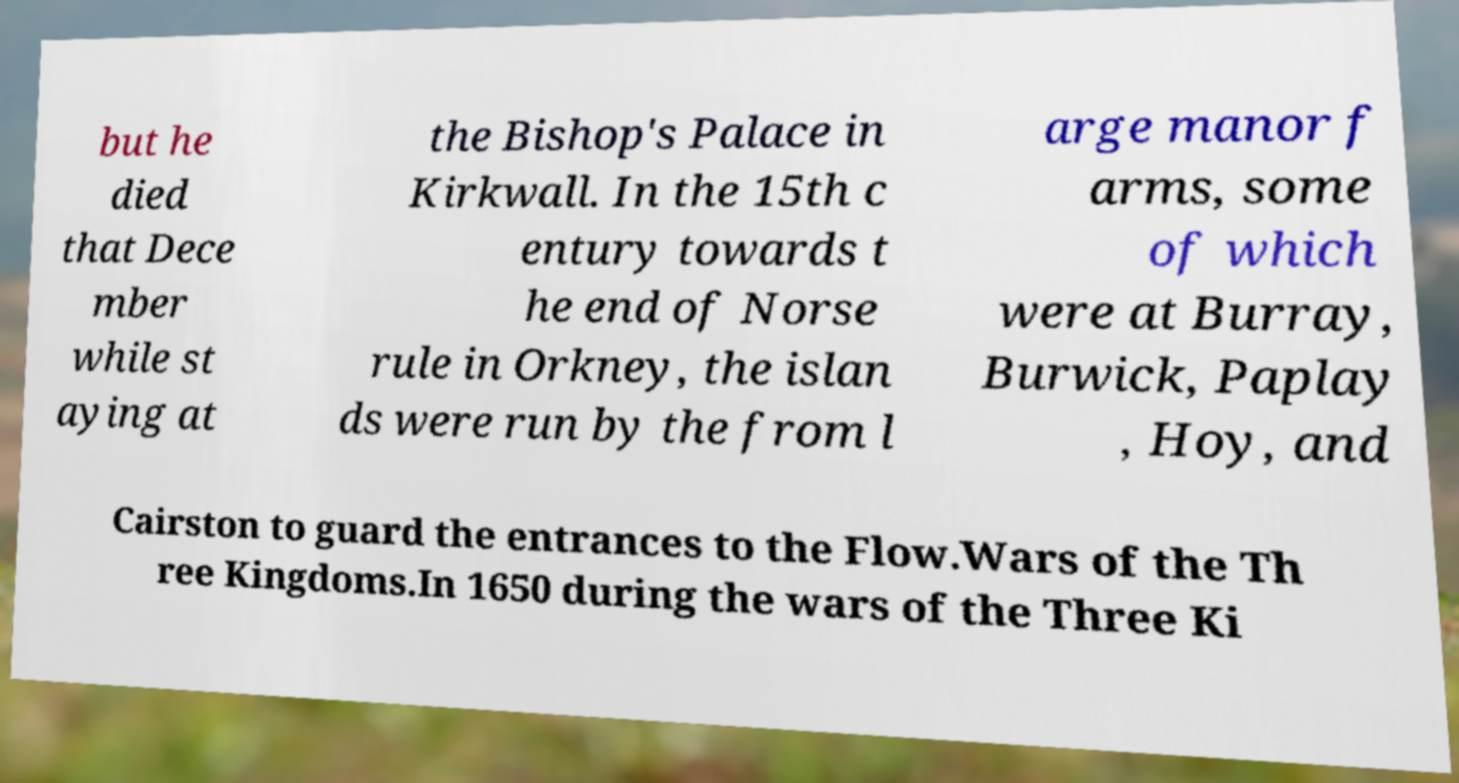Can you accurately transcribe the text from the provided image for me? but he died that Dece mber while st aying at the Bishop's Palace in Kirkwall. In the 15th c entury towards t he end of Norse rule in Orkney, the islan ds were run by the from l arge manor f arms, some of which were at Burray, Burwick, Paplay , Hoy, and Cairston to guard the entrances to the Flow.Wars of the Th ree Kingdoms.In 1650 during the wars of the Three Ki 